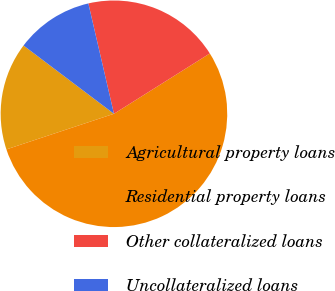<chart> <loc_0><loc_0><loc_500><loc_500><pie_chart><fcel>Agricultural property loans<fcel>Residential property loans<fcel>Other collateralized loans<fcel>Uncollateralized loans<nl><fcel>15.38%<fcel>53.85%<fcel>19.69%<fcel>11.08%<nl></chart> 